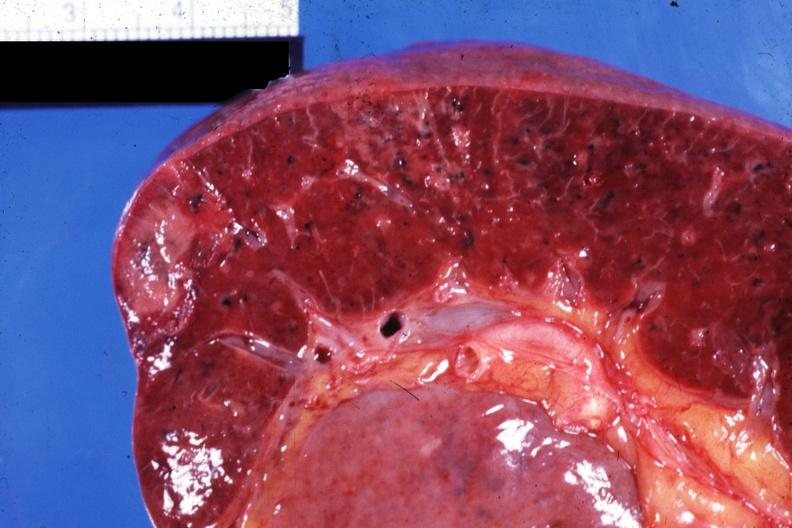where is this part in?
Answer the question using a single word or phrase. Spleen 